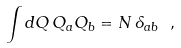Convert formula to latex. <formula><loc_0><loc_0><loc_500><loc_500>\int d Q \, Q _ { a } Q _ { b } = N \, \delta _ { a b } \ ,</formula> 